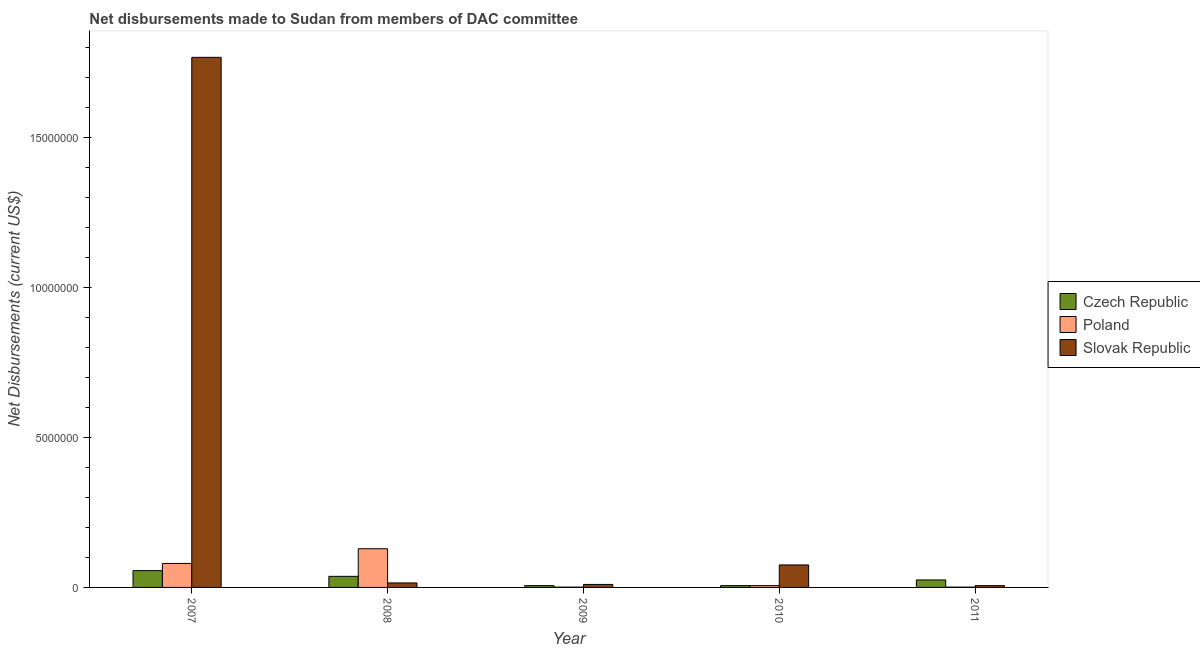How many different coloured bars are there?
Provide a succinct answer. 3. How many groups of bars are there?
Ensure brevity in your answer.  5. Are the number of bars per tick equal to the number of legend labels?
Provide a short and direct response. Yes. How many bars are there on the 3rd tick from the right?
Keep it short and to the point. 3. In how many cases, is the number of bars for a given year not equal to the number of legend labels?
Your response must be concise. 0. What is the net disbursements made by slovak republic in 2009?
Ensure brevity in your answer.  1.00e+05. Across all years, what is the maximum net disbursements made by slovak republic?
Keep it short and to the point. 1.77e+07. Across all years, what is the minimum net disbursements made by slovak republic?
Ensure brevity in your answer.  6.00e+04. In which year was the net disbursements made by slovak republic minimum?
Ensure brevity in your answer.  2011. What is the total net disbursements made by slovak republic in the graph?
Ensure brevity in your answer.  1.87e+07. What is the difference between the net disbursements made by slovak republic in 2008 and that in 2010?
Offer a terse response. -6.00e+05. What is the difference between the net disbursements made by czech republic in 2010 and the net disbursements made by slovak republic in 2011?
Keep it short and to the point. -1.90e+05. What is the average net disbursements made by poland per year?
Your answer should be compact. 4.34e+05. In the year 2010, what is the difference between the net disbursements made by czech republic and net disbursements made by poland?
Keep it short and to the point. 0. In how many years, is the net disbursements made by slovak republic greater than 16000000 US$?
Provide a short and direct response. 1. What is the ratio of the net disbursements made by slovak republic in 2009 to that in 2010?
Offer a very short reply. 0.13. Is the net disbursements made by czech republic in 2009 less than that in 2010?
Your answer should be compact. No. What is the difference between the highest and the lowest net disbursements made by poland?
Give a very brief answer. 1.28e+06. Is the sum of the net disbursements made by slovak republic in 2007 and 2011 greater than the maximum net disbursements made by poland across all years?
Ensure brevity in your answer.  Yes. What does the 1st bar from the left in 2010 represents?
Your response must be concise. Czech Republic. What does the 3rd bar from the right in 2010 represents?
Make the answer very short. Czech Republic. Is it the case that in every year, the sum of the net disbursements made by czech republic and net disbursements made by poland is greater than the net disbursements made by slovak republic?
Offer a terse response. No. What is the difference between two consecutive major ticks on the Y-axis?
Your response must be concise. 5.00e+06. How are the legend labels stacked?
Give a very brief answer. Vertical. What is the title of the graph?
Make the answer very short. Net disbursements made to Sudan from members of DAC committee. What is the label or title of the Y-axis?
Your answer should be very brief. Net Disbursements (current US$). What is the Net Disbursements (current US$) of Czech Republic in 2007?
Offer a terse response. 5.60e+05. What is the Net Disbursements (current US$) of Poland in 2007?
Give a very brief answer. 8.00e+05. What is the Net Disbursements (current US$) of Slovak Republic in 2007?
Your answer should be very brief. 1.77e+07. What is the Net Disbursements (current US$) in Poland in 2008?
Make the answer very short. 1.29e+06. What is the Net Disbursements (current US$) of Czech Republic in 2009?
Provide a succinct answer. 6.00e+04. What is the Net Disbursements (current US$) in Poland in 2009?
Your answer should be very brief. 10000. What is the Net Disbursements (current US$) in Slovak Republic in 2009?
Provide a succinct answer. 1.00e+05. What is the Net Disbursements (current US$) of Czech Republic in 2010?
Offer a terse response. 6.00e+04. What is the Net Disbursements (current US$) in Poland in 2010?
Keep it short and to the point. 6.00e+04. What is the Net Disbursements (current US$) of Slovak Republic in 2010?
Your response must be concise. 7.50e+05. What is the Net Disbursements (current US$) in Slovak Republic in 2011?
Your answer should be compact. 6.00e+04. Across all years, what is the maximum Net Disbursements (current US$) of Czech Republic?
Provide a short and direct response. 5.60e+05. Across all years, what is the maximum Net Disbursements (current US$) of Poland?
Make the answer very short. 1.29e+06. Across all years, what is the maximum Net Disbursements (current US$) in Slovak Republic?
Ensure brevity in your answer.  1.77e+07. What is the total Net Disbursements (current US$) of Czech Republic in the graph?
Give a very brief answer. 1.30e+06. What is the total Net Disbursements (current US$) in Poland in the graph?
Provide a succinct answer. 2.17e+06. What is the total Net Disbursements (current US$) in Slovak Republic in the graph?
Your response must be concise. 1.87e+07. What is the difference between the Net Disbursements (current US$) of Poland in 2007 and that in 2008?
Offer a very short reply. -4.90e+05. What is the difference between the Net Disbursements (current US$) in Slovak Republic in 2007 and that in 2008?
Offer a terse response. 1.75e+07. What is the difference between the Net Disbursements (current US$) in Poland in 2007 and that in 2009?
Offer a terse response. 7.90e+05. What is the difference between the Net Disbursements (current US$) of Slovak Republic in 2007 and that in 2009?
Your answer should be very brief. 1.76e+07. What is the difference between the Net Disbursements (current US$) of Poland in 2007 and that in 2010?
Offer a very short reply. 7.40e+05. What is the difference between the Net Disbursements (current US$) in Slovak Republic in 2007 and that in 2010?
Your answer should be very brief. 1.69e+07. What is the difference between the Net Disbursements (current US$) in Czech Republic in 2007 and that in 2011?
Ensure brevity in your answer.  3.10e+05. What is the difference between the Net Disbursements (current US$) in Poland in 2007 and that in 2011?
Keep it short and to the point. 7.90e+05. What is the difference between the Net Disbursements (current US$) in Slovak Republic in 2007 and that in 2011?
Make the answer very short. 1.76e+07. What is the difference between the Net Disbursements (current US$) in Czech Republic in 2008 and that in 2009?
Ensure brevity in your answer.  3.10e+05. What is the difference between the Net Disbursements (current US$) of Poland in 2008 and that in 2009?
Give a very brief answer. 1.28e+06. What is the difference between the Net Disbursements (current US$) in Czech Republic in 2008 and that in 2010?
Provide a succinct answer. 3.10e+05. What is the difference between the Net Disbursements (current US$) in Poland in 2008 and that in 2010?
Make the answer very short. 1.23e+06. What is the difference between the Net Disbursements (current US$) in Slovak Republic in 2008 and that in 2010?
Keep it short and to the point. -6.00e+05. What is the difference between the Net Disbursements (current US$) in Poland in 2008 and that in 2011?
Provide a short and direct response. 1.28e+06. What is the difference between the Net Disbursements (current US$) of Slovak Republic in 2009 and that in 2010?
Offer a terse response. -6.50e+05. What is the difference between the Net Disbursements (current US$) in Czech Republic in 2009 and that in 2011?
Your answer should be very brief. -1.90e+05. What is the difference between the Net Disbursements (current US$) of Slovak Republic in 2010 and that in 2011?
Offer a very short reply. 6.90e+05. What is the difference between the Net Disbursements (current US$) in Czech Republic in 2007 and the Net Disbursements (current US$) in Poland in 2008?
Give a very brief answer. -7.30e+05. What is the difference between the Net Disbursements (current US$) of Czech Republic in 2007 and the Net Disbursements (current US$) of Slovak Republic in 2008?
Provide a short and direct response. 4.10e+05. What is the difference between the Net Disbursements (current US$) of Poland in 2007 and the Net Disbursements (current US$) of Slovak Republic in 2008?
Your response must be concise. 6.50e+05. What is the difference between the Net Disbursements (current US$) in Poland in 2007 and the Net Disbursements (current US$) in Slovak Republic in 2011?
Offer a very short reply. 7.40e+05. What is the difference between the Net Disbursements (current US$) in Czech Republic in 2008 and the Net Disbursements (current US$) in Slovak Republic in 2009?
Your answer should be compact. 2.70e+05. What is the difference between the Net Disbursements (current US$) in Poland in 2008 and the Net Disbursements (current US$) in Slovak Republic in 2009?
Provide a succinct answer. 1.19e+06. What is the difference between the Net Disbursements (current US$) in Czech Republic in 2008 and the Net Disbursements (current US$) in Slovak Republic in 2010?
Keep it short and to the point. -3.80e+05. What is the difference between the Net Disbursements (current US$) of Poland in 2008 and the Net Disbursements (current US$) of Slovak Republic in 2010?
Offer a very short reply. 5.40e+05. What is the difference between the Net Disbursements (current US$) of Poland in 2008 and the Net Disbursements (current US$) of Slovak Republic in 2011?
Provide a succinct answer. 1.23e+06. What is the difference between the Net Disbursements (current US$) in Czech Republic in 2009 and the Net Disbursements (current US$) in Slovak Republic in 2010?
Provide a short and direct response. -6.90e+05. What is the difference between the Net Disbursements (current US$) of Poland in 2009 and the Net Disbursements (current US$) of Slovak Republic in 2010?
Ensure brevity in your answer.  -7.40e+05. What is the difference between the Net Disbursements (current US$) of Czech Republic in 2009 and the Net Disbursements (current US$) of Slovak Republic in 2011?
Your answer should be very brief. 0. What is the difference between the Net Disbursements (current US$) of Poland in 2009 and the Net Disbursements (current US$) of Slovak Republic in 2011?
Your answer should be compact. -5.00e+04. What is the difference between the Net Disbursements (current US$) of Czech Republic in 2010 and the Net Disbursements (current US$) of Slovak Republic in 2011?
Ensure brevity in your answer.  0. What is the difference between the Net Disbursements (current US$) of Poland in 2010 and the Net Disbursements (current US$) of Slovak Republic in 2011?
Provide a short and direct response. 0. What is the average Net Disbursements (current US$) in Poland per year?
Keep it short and to the point. 4.34e+05. What is the average Net Disbursements (current US$) in Slovak Republic per year?
Provide a succinct answer. 3.75e+06. In the year 2007, what is the difference between the Net Disbursements (current US$) in Czech Republic and Net Disbursements (current US$) in Poland?
Give a very brief answer. -2.40e+05. In the year 2007, what is the difference between the Net Disbursements (current US$) of Czech Republic and Net Disbursements (current US$) of Slovak Republic?
Provide a succinct answer. -1.71e+07. In the year 2007, what is the difference between the Net Disbursements (current US$) in Poland and Net Disbursements (current US$) in Slovak Republic?
Make the answer very short. -1.69e+07. In the year 2008, what is the difference between the Net Disbursements (current US$) of Czech Republic and Net Disbursements (current US$) of Poland?
Your answer should be very brief. -9.20e+05. In the year 2008, what is the difference between the Net Disbursements (current US$) of Poland and Net Disbursements (current US$) of Slovak Republic?
Provide a succinct answer. 1.14e+06. In the year 2009, what is the difference between the Net Disbursements (current US$) in Czech Republic and Net Disbursements (current US$) in Poland?
Make the answer very short. 5.00e+04. In the year 2009, what is the difference between the Net Disbursements (current US$) in Czech Republic and Net Disbursements (current US$) in Slovak Republic?
Your answer should be very brief. -4.00e+04. In the year 2010, what is the difference between the Net Disbursements (current US$) in Czech Republic and Net Disbursements (current US$) in Poland?
Your answer should be compact. 0. In the year 2010, what is the difference between the Net Disbursements (current US$) in Czech Republic and Net Disbursements (current US$) in Slovak Republic?
Offer a very short reply. -6.90e+05. In the year 2010, what is the difference between the Net Disbursements (current US$) in Poland and Net Disbursements (current US$) in Slovak Republic?
Your response must be concise. -6.90e+05. In the year 2011, what is the difference between the Net Disbursements (current US$) of Czech Republic and Net Disbursements (current US$) of Poland?
Your answer should be compact. 2.40e+05. In the year 2011, what is the difference between the Net Disbursements (current US$) in Czech Republic and Net Disbursements (current US$) in Slovak Republic?
Offer a terse response. 1.90e+05. What is the ratio of the Net Disbursements (current US$) in Czech Republic in 2007 to that in 2008?
Your response must be concise. 1.51. What is the ratio of the Net Disbursements (current US$) in Poland in 2007 to that in 2008?
Offer a terse response. 0.62. What is the ratio of the Net Disbursements (current US$) in Slovak Republic in 2007 to that in 2008?
Give a very brief answer. 117.87. What is the ratio of the Net Disbursements (current US$) of Czech Republic in 2007 to that in 2009?
Your response must be concise. 9.33. What is the ratio of the Net Disbursements (current US$) of Poland in 2007 to that in 2009?
Offer a very short reply. 80. What is the ratio of the Net Disbursements (current US$) of Slovak Republic in 2007 to that in 2009?
Provide a short and direct response. 176.8. What is the ratio of the Net Disbursements (current US$) in Czech Republic in 2007 to that in 2010?
Give a very brief answer. 9.33. What is the ratio of the Net Disbursements (current US$) of Poland in 2007 to that in 2010?
Your response must be concise. 13.33. What is the ratio of the Net Disbursements (current US$) in Slovak Republic in 2007 to that in 2010?
Your answer should be very brief. 23.57. What is the ratio of the Net Disbursements (current US$) of Czech Republic in 2007 to that in 2011?
Offer a terse response. 2.24. What is the ratio of the Net Disbursements (current US$) in Slovak Republic in 2007 to that in 2011?
Your answer should be very brief. 294.67. What is the ratio of the Net Disbursements (current US$) in Czech Republic in 2008 to that in 2009?
Your answer should be very brief. 6.17. What is the ratio of the Net Disbursements (current US$) in Poland in 2008 to that in 2009?
Ensure brevity in your answer.  129. What is the ratio of the Net Disbursements (current US$) in Czech Republic in 2008 to that in 2010?
Offer a terse response. 6.17. What is the ratio of the Net Disbursements (current US$) in Poland in 2008 to that in 2010?
Make the answer very short. 21.5. What is the ratio of the Net Disbursements (current US$) of Slovak Republic in 2008 to that in 2010?
Ensure brevity in your answer.  0.2. What is the ratio of the Net Disbursements (current US$) in Czech Republic in 2008 to that in 2011?
Your answer should be compact. 1.48. What is the ratio of the Net Disbursements (current US$) of Poland in 2008 to that in 2011?
Your response must be concise. 129. What is the ratio of the Net Disbursements (current US$) in Poland in 2009 to that in 2010?
Keep it short and to the point. 0.17. What is the ratio of the Net Disbursements (current US$) of Slovak Republic in 2009 to that in 2010?
Provide a succinct answer. 0.13. What is the ratio of the Net Disbursements (current US$) in Czech Republic in 2009 to that in 2011?
Give a very brief answer. 0.24. What is the ratio of the Net Disbursements (current US$) of Poland in 2009 to that in 2011?
Your answer should be very brief. 1. What is the ratio of the Net Disbursements (current US$) of Slovak Republic in 2009 to that in 2011?
Offer a terse response. 1.67. What is the ratio of the Net Disbursements (current US$) in Czech Republic in 2010 to that in 2011?
Your response must be concise. 0.24. What is the ratio of the Net Disbursements (current US$) of Poland in 2010 to that in 2011?
Your answer should be very brief. 6. What is the ratio of the Net Disbursements (current US$) in Slovak Republic in 2010 to that in 2011?
Make the answer very short. 12.5. What is the difference between the highest and the second highest Net Disbursements (current US$) of Czech Republic?
Offer a very short reply. 1.90e+05. What is the difference between the highest and the second highest Net Disbursements (current US$) in Poland?
Your answer should be compact. 4.90e+05. What is the difference between the highest and the second highest Net Disbursements (current US$) of Slovak Republic?
Offer a terse response. 1.69e+07. What is the difference between the highest and the lowest Net Disbursements (current US$) of Poland?
Offer a terse response. 1.28e+06. What is the difference between the highest and the lowest Net Disbursements (current US$) in Slovak Republic?
Give a very brief answer. 1.76e+07. 